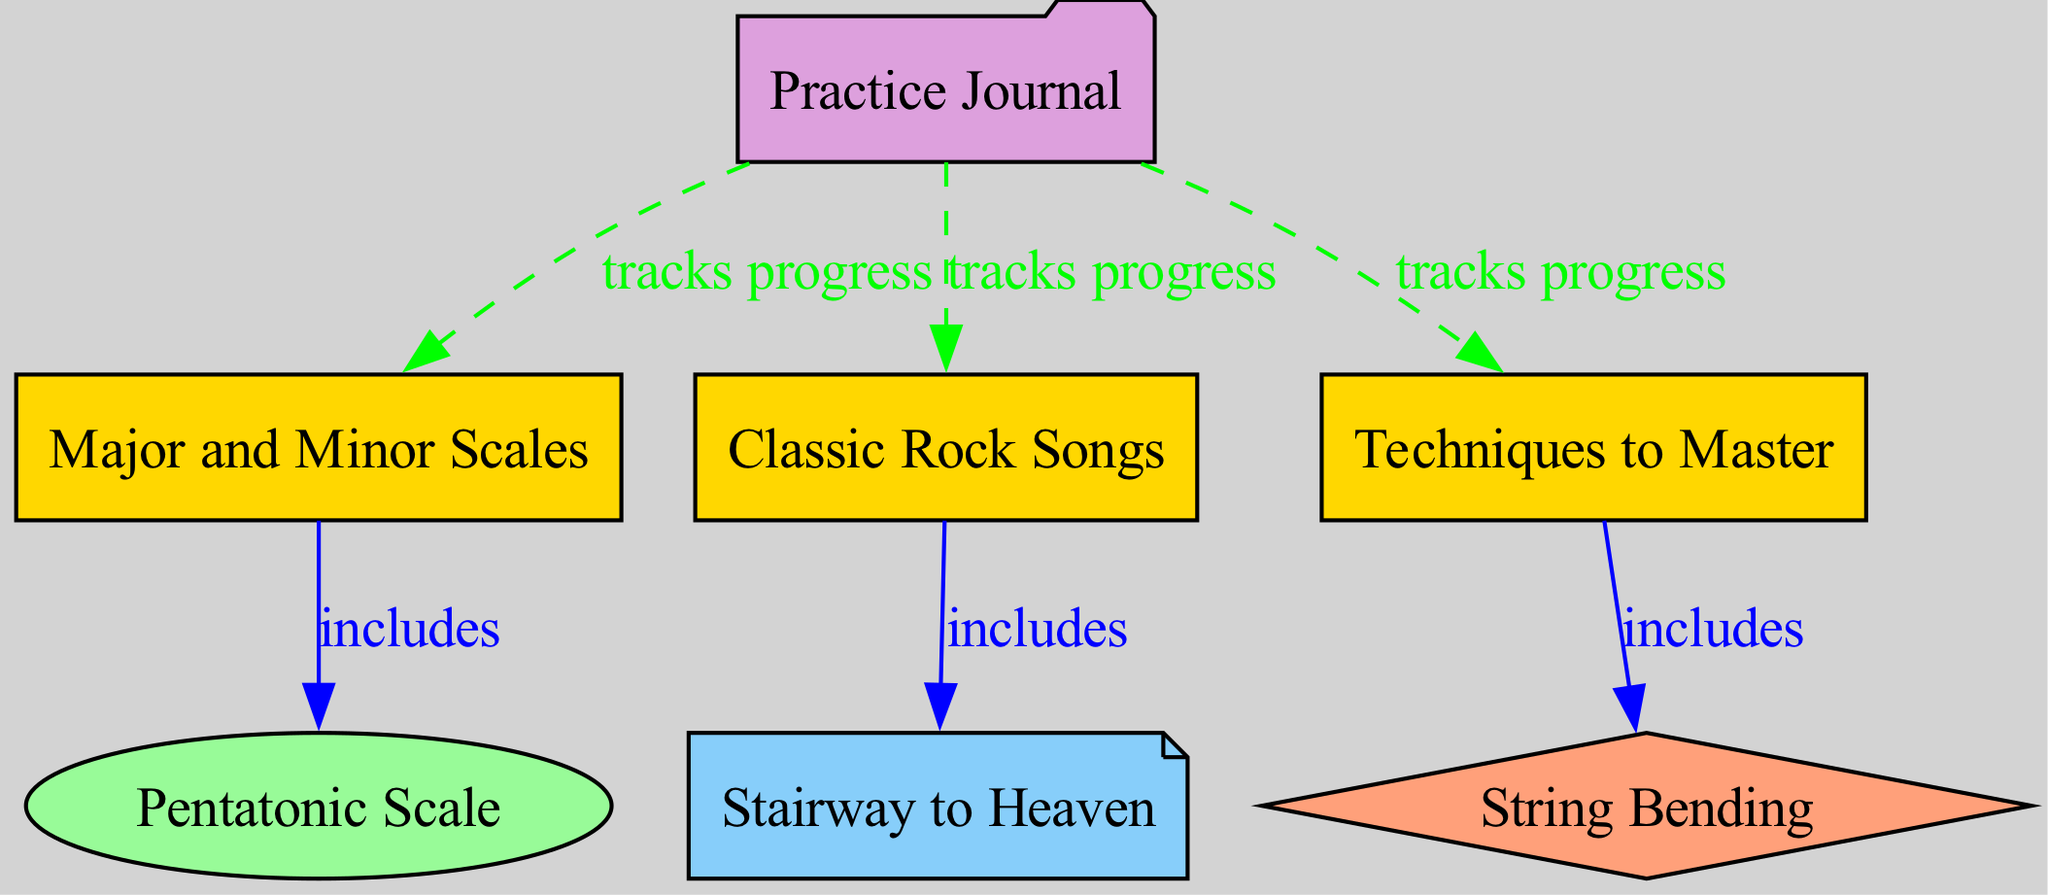What is the main category that includes the Pentatonic Scale? The Pentatonic Scale is a subcategory under the Major and Minor Scales category, indicating that it plays a role within the larger context of fundamental scales for guitar practice.
Answer: Major and Minor Scales Which song is included under the category of Classic Rock Songs? The relationship shows that the song "Stairway to Heaven" is specifically noted as being part of the Classic Rock Songs category, marking its significance in the practice routine.
Answer: Stairway to Heaven How many techniques are tracked in the Practice Journal? The Practice Journal tracks progress for three distinct categories: Major and Minor Scales, Classic Rock Songs, and Techniques to Master, thereby indicating the breadth of the practice areas it covers.
Answer: Three What relationship type connects the Major and Minor Scales to the Pentatonic Scale? The connection between these two elements is labeled as "includes," which signifies that the Pentatonic Scale is considered a component or subset of the broader Major and Minor Scales category.
Answer: Includes Which technique is specifically related to string bending? The diagram outlines that String Bending is categorized under Techniques to Master, highlighting it as an essential skill for expressive solos in guitar playing.
Answer: String Bending What type of edges are used to represent the tracking of progress in the Practice Journal? The edges connecting the Practice Journal to each category employ a dashed line style, which explicitly indicates that these relationships involve tracking progress rather than inclusion.
Answer: Dashed How many categories are represented in the diagram? By counting the distinct nodes labeled as Categories (Major and Minor Scales, Classic Rock Songs, Techniques to Master), we can identify that there are three primary categories represented.
Answer: Three Which category does the Practice Journal track progress for? The Practice Journal tracks progress specifically for three categories: Major and Minor Scales, Classic Rock Songs, and Techniques to Master, illustrating its comprehensive function.
Answer: Three categories 